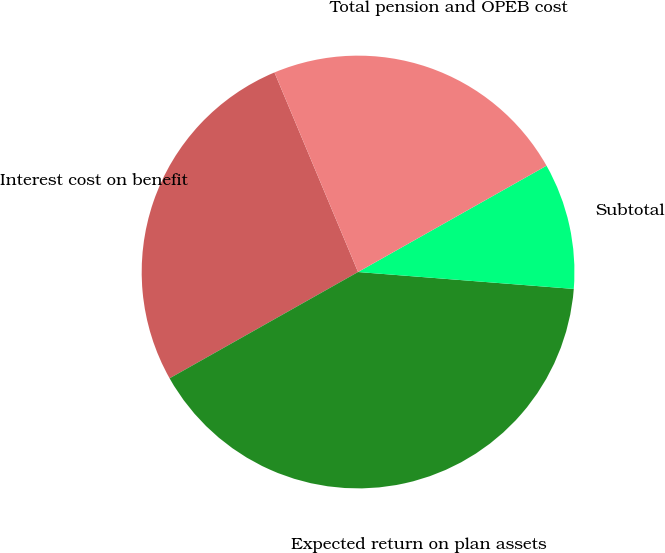<chart> <loc_0><loc_0><loc_500><loc_500><pie_chart><fcel>Interest cost on benefit<fcel>Expected return on plan assets<fcel>Subtotal<fcel>Total pension and OPEB cost<nl><fcel>26.86%<fcel>40.58%<fcel>9.42%<fcel>23.14%<nl></chart> 